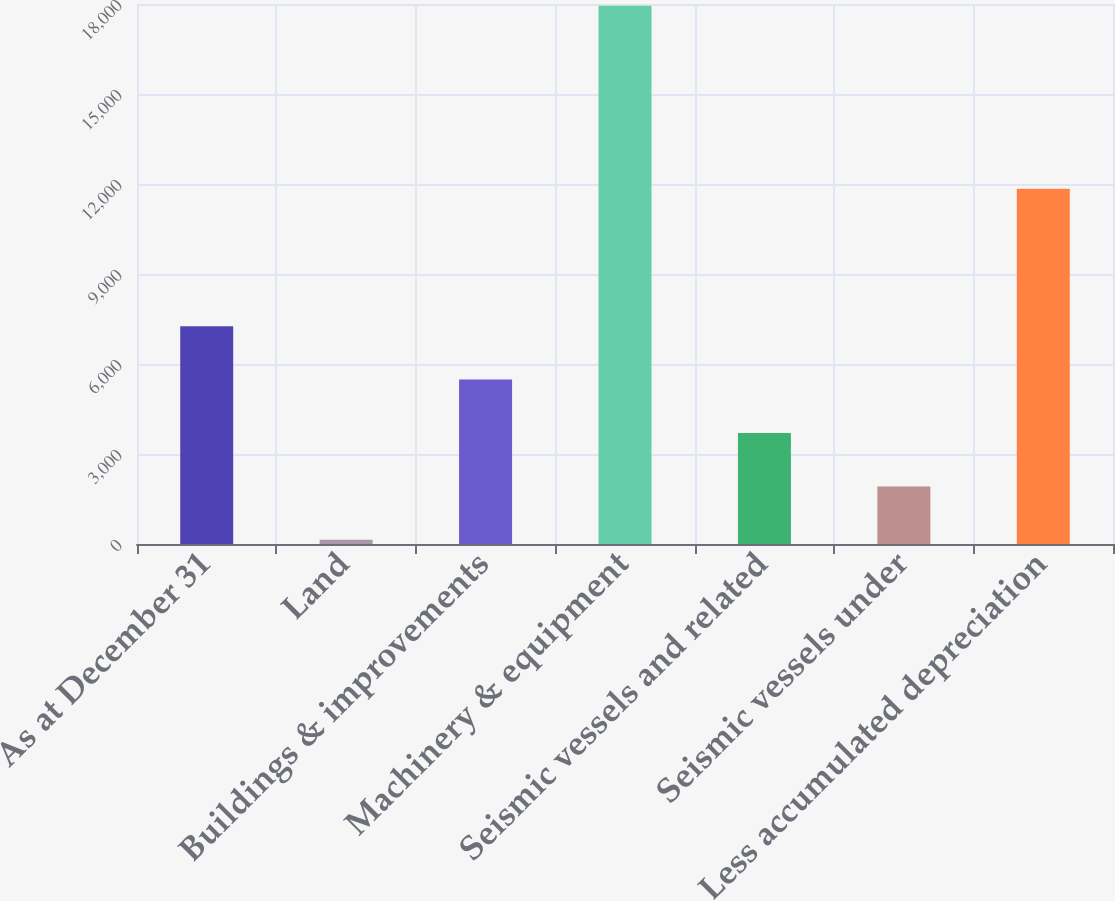<chart> <loc_0><loc_0><loc_500><loc_500><bar_chart><fcel>As at December 31<fcel>Land<fcel>Buildings & improvements<fcel>Machinery & equipment<fcel>Seismic vessels and related<fcel>Seismic vessels under<fcel>Less accumulated depreciation<nl><fcel>7260.2<fcel>141<fcel>5480.4<fcel>17939<fcel>3700.6<fcel>1920.8<fcel>11845<nl></chart> 